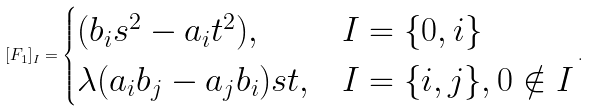<formula> <loc_0><loc_0><loc_500><loc_500>[ F _ { 1 } ] _ { I } = \begin{cases} ( b _ { i } s ^ { 2 } - a _ { i } t ^ { 2 } ) , & I = \{ 0 , i \} \\ \lambda ( a _ { i } b _ { j } - a _ { j } b _ { i } ) s t , & I = \{ i , j \} , 0 \notin I \end{cases} .</formula> 